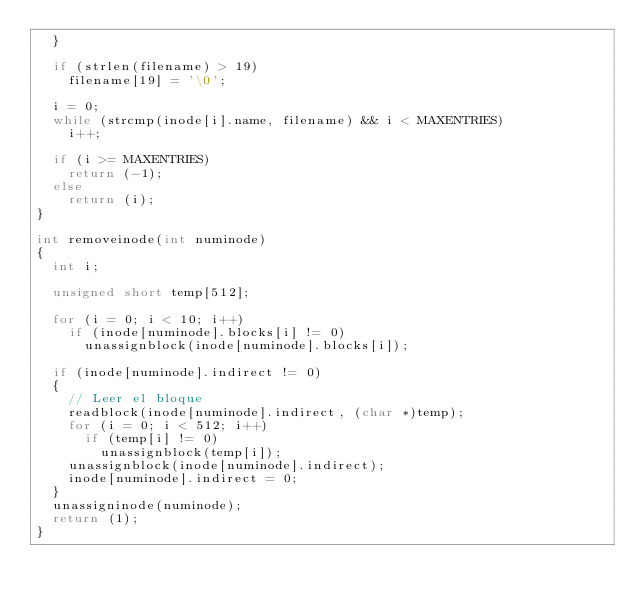<code> <loc_0><loc_0><loc_500><loc_500><_C_>	}

	if (strlen(filename) > 19)
		filename[19] = '\0';

	i = 0;
	while (strcmp(inode[i].name, filename) && i < MAXENTRIES)
		i++;

	if (i >= MAXENTRIES)
		return (-1);
	else
		return (i);
}

int removeinode(int numinode)
{
	int i;

	unsigned short temp[512];

	for (i = 0; i < 10; i++)
		if (inode[numinode].blocks[i] != 0)
			unassignblock(inode[numinode].blocks[i]);

	if (inode[numinode].indirect != 0)
	{
		// Leer el bloque
		readblock(inode[numinode].indirect, (char *)temp);
		for (i = 0; i < 512; i++)
			if (temp[i] != 0)
				unassignblock(temp[i]);
		unassignblock(inode[numinode].indirect);
		inode[numinode].indirect = 0;
	}
	unassigninode(numinode);
	return (1);
}
</code> 